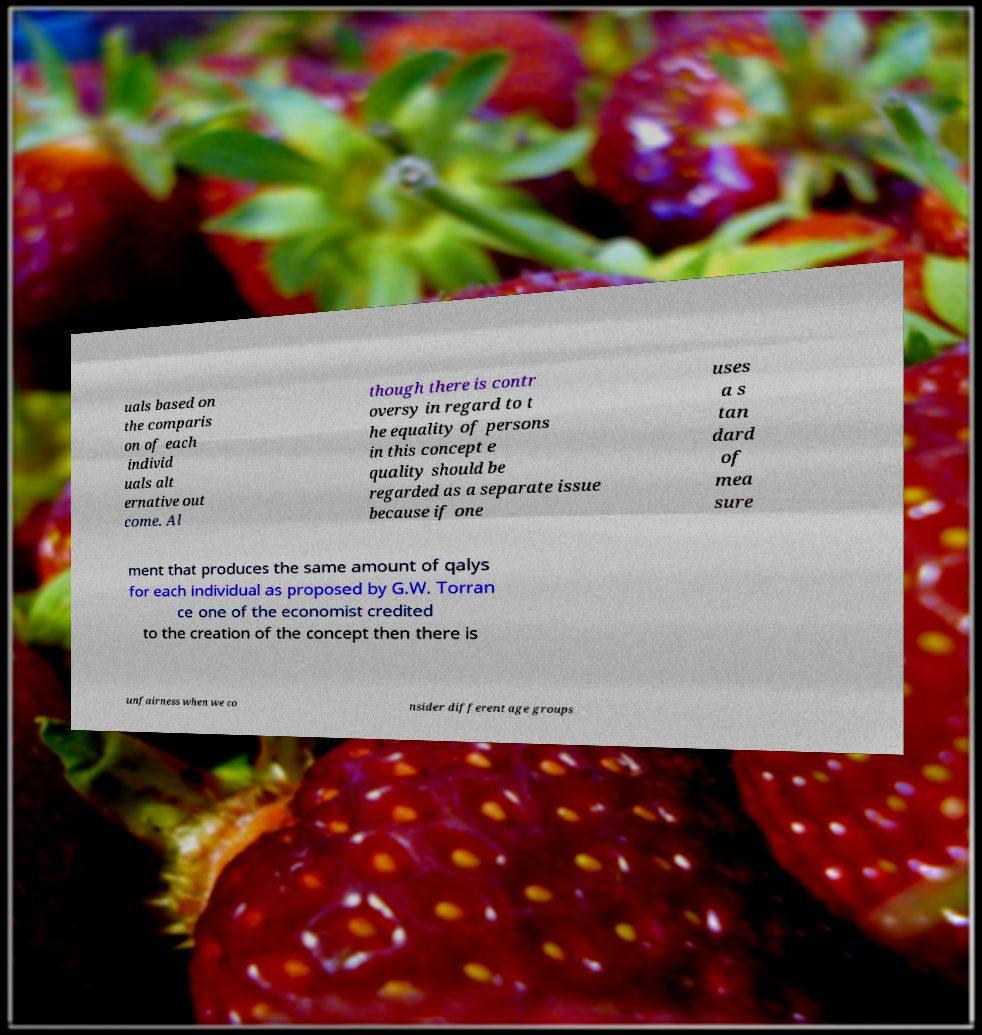Could you assist in decoding the text presented in this image and type it out clearly? uals based on the comparis on of each individ uals alt ernative out come. Al though there is contr oversy in regard to t he equality of persons in this concept e quality should be regarded as a separate issue because if one uses a s tan dard of mea sure ment that produces the same amount of qalys for each individual as proposed by G.W. Torran ce one of the economist credited to the creation of the concept then there is unfairness when we co nsider different age groups 